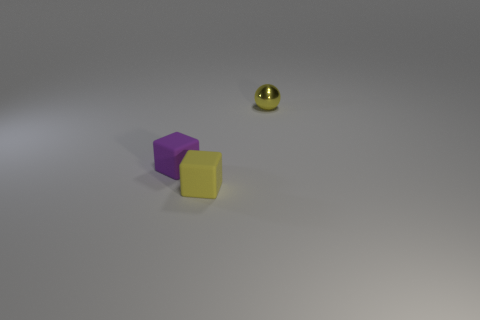Are there any yellow things that have the same material as the yellow ball?
Your answer should be compact. No. Does the block that is in front of the purple cube have the same size as the metallic ball?
Your answer should be compact. Yes. There is a tiny yellow object that is left of the yellow object behind the purple rubber thing; are there any rubber objects in front of it?
Give a very brief answer. No. What number of rubber things are either large green cylinders or purple blocks?
Your answer should be very brief. 1. What number of other objects are the same shape as the tiny purple object?
Give a very brief answer. 1. Are there more yellow objects than small purple rubber blocks?
Offer a terse response. Yes. There is a matte object behind the small rubber object in front of the tiny rubber block that is to the left of the yellow block; what is its size?
Ensure brevity in your answer.  Small. There is a yellow object that is on the left side of the tiny metallic object; what is its size?
Offer a terse response. Small. What number of objects are purple matte blocks or small objects that are in front of the yellow ball?
Give a very brief answer. 2. What number of other objects are there of the same size as the yellow matte thing?
Ensure brevity in your answer.  2. 